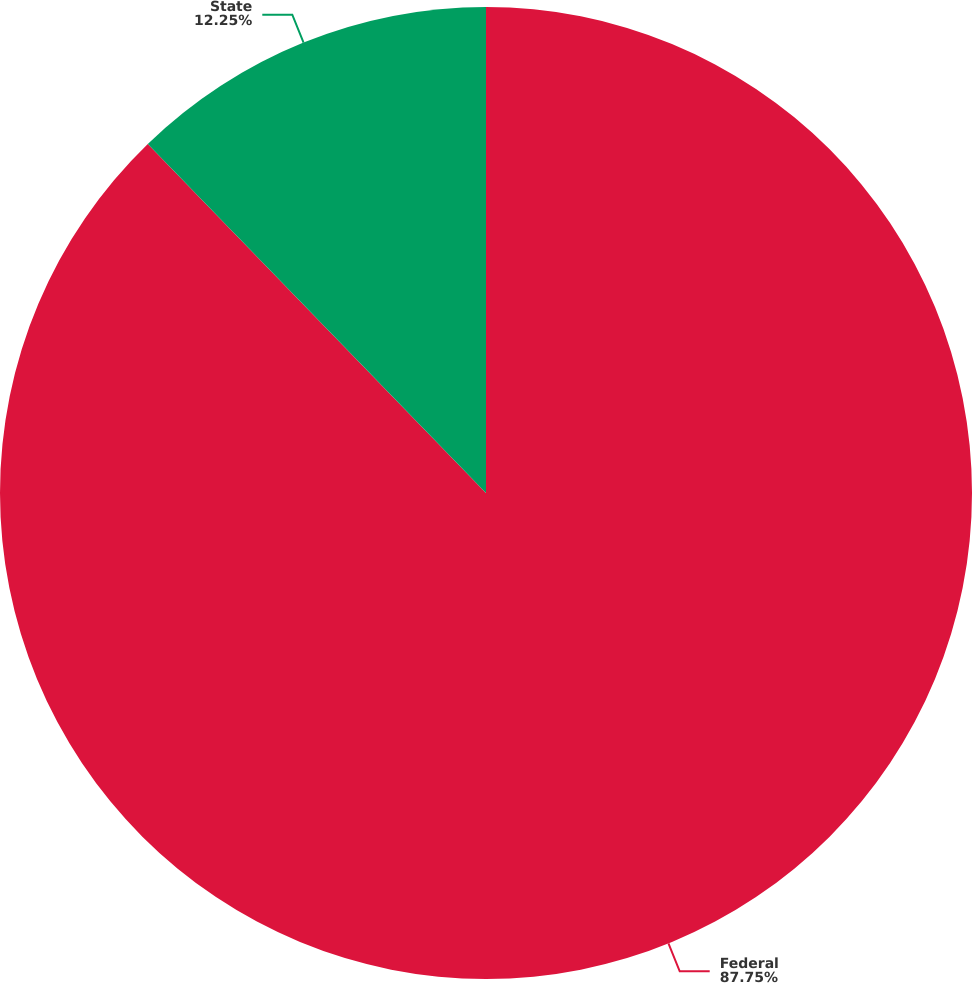Convert chart. <chart><loc_0><loc_0><loc_500><loc_500><pie_chart><fcel>Federal<fcel>State<nl><fcel>87.75%<fcel>12.25%<nl></chart> 